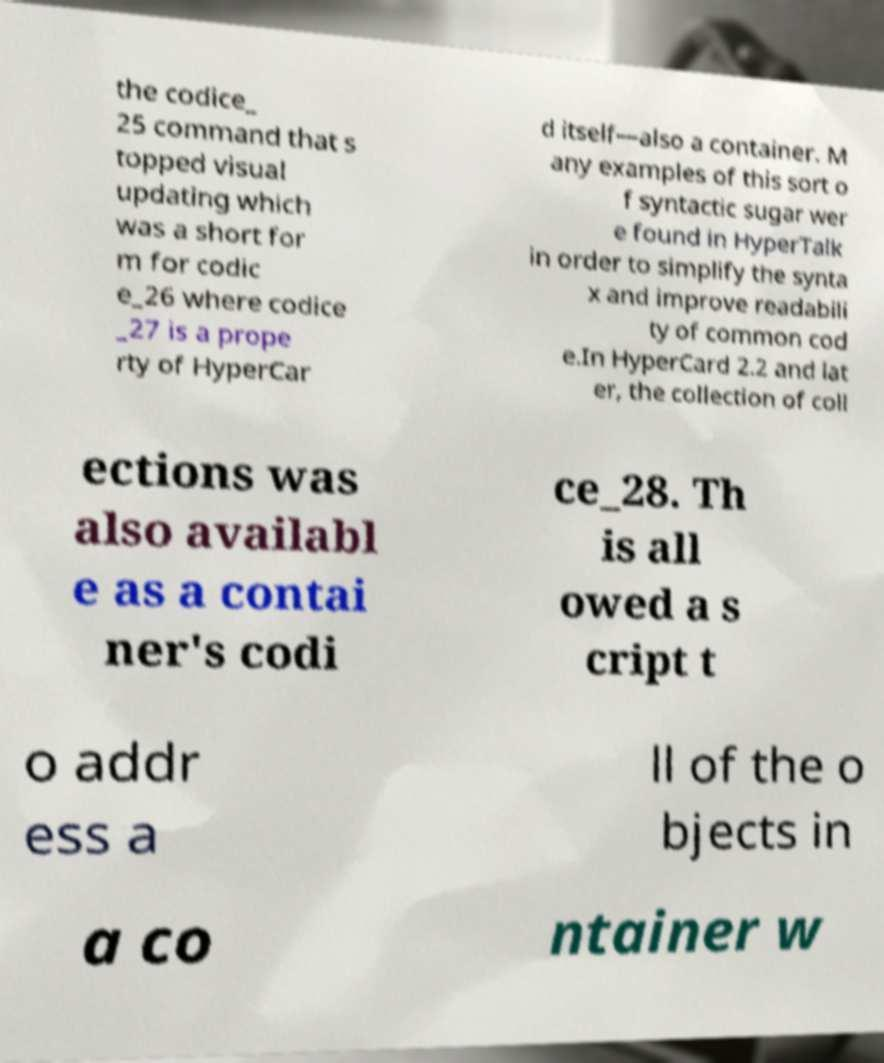Can you accurately transcribe the text from the provided image for me? the codice_ 25 command that s topped visual updating which was a short for m for codic e_26 where codice _27 is a prope rty of HyperCar d itself—also a container. M any examples of this sort o f syntactic sugar wer e found in HyperTalk in order to simplify the synta x and improve readabili ty of common cod e.In HyperCard 2.2 and lat er, the collection of coll ections was also availabl e as a contai ner's codi ce_28. Th is all owed a s cript t o addr ess a ll of the o bjects in a co ntainer w 